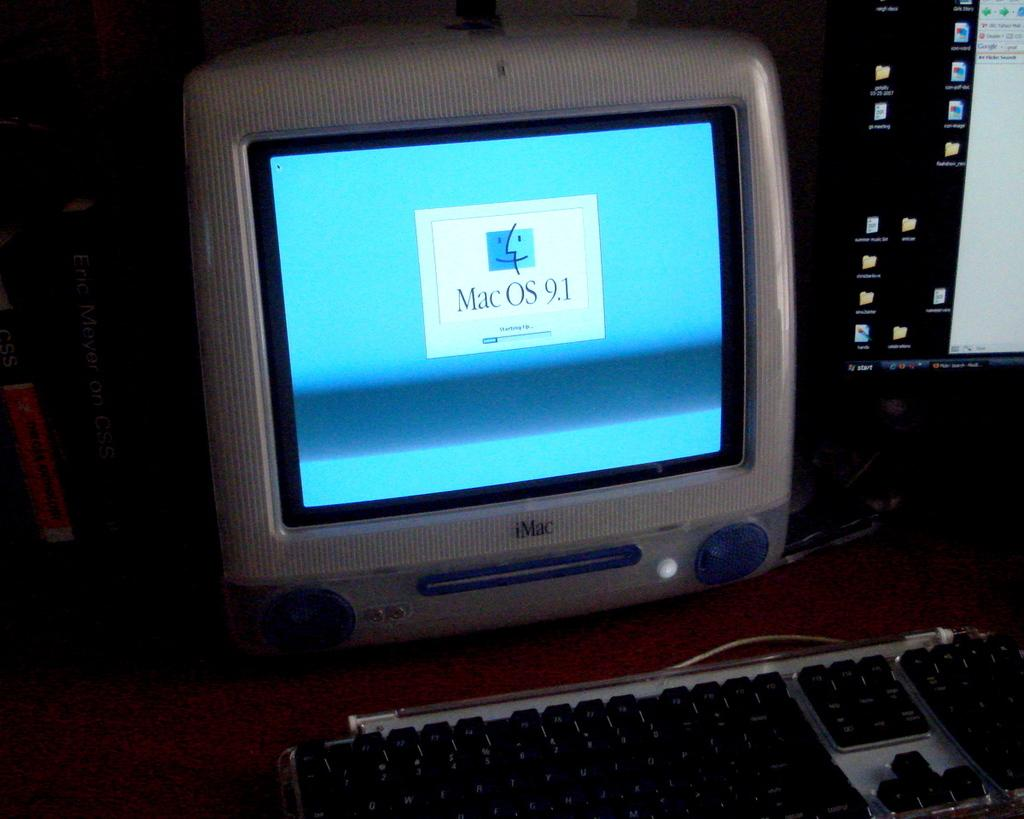<image>
Describe the image concisely. An old computer shows the startup screen for Mac OS 9.1. 